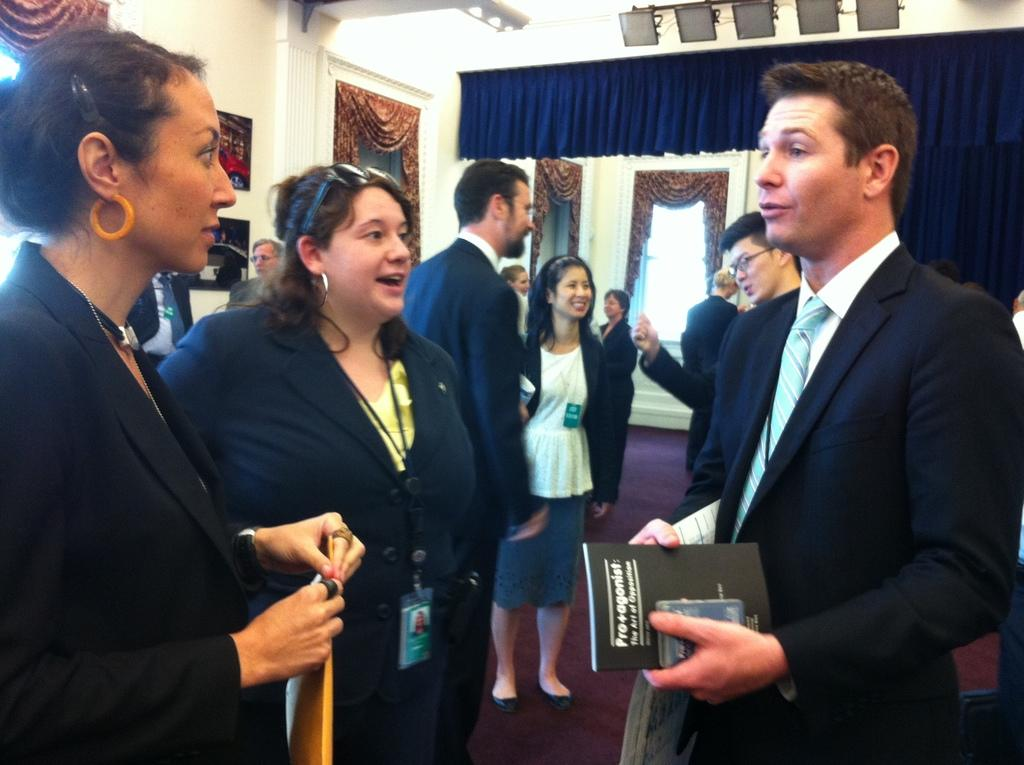What is happening with the group of people in the image? The group of people is on the ground in the image. What are some people in the group holding? Some people in the group are holding files. What can be seen in the background of the image? There is a wall, photo frames, curtains, and some objects visible in the background of the image. Where is the patch of grass located in the image? There is no patch of grass present in the image. What type of map is visible in the image? There is no map present in the image. 